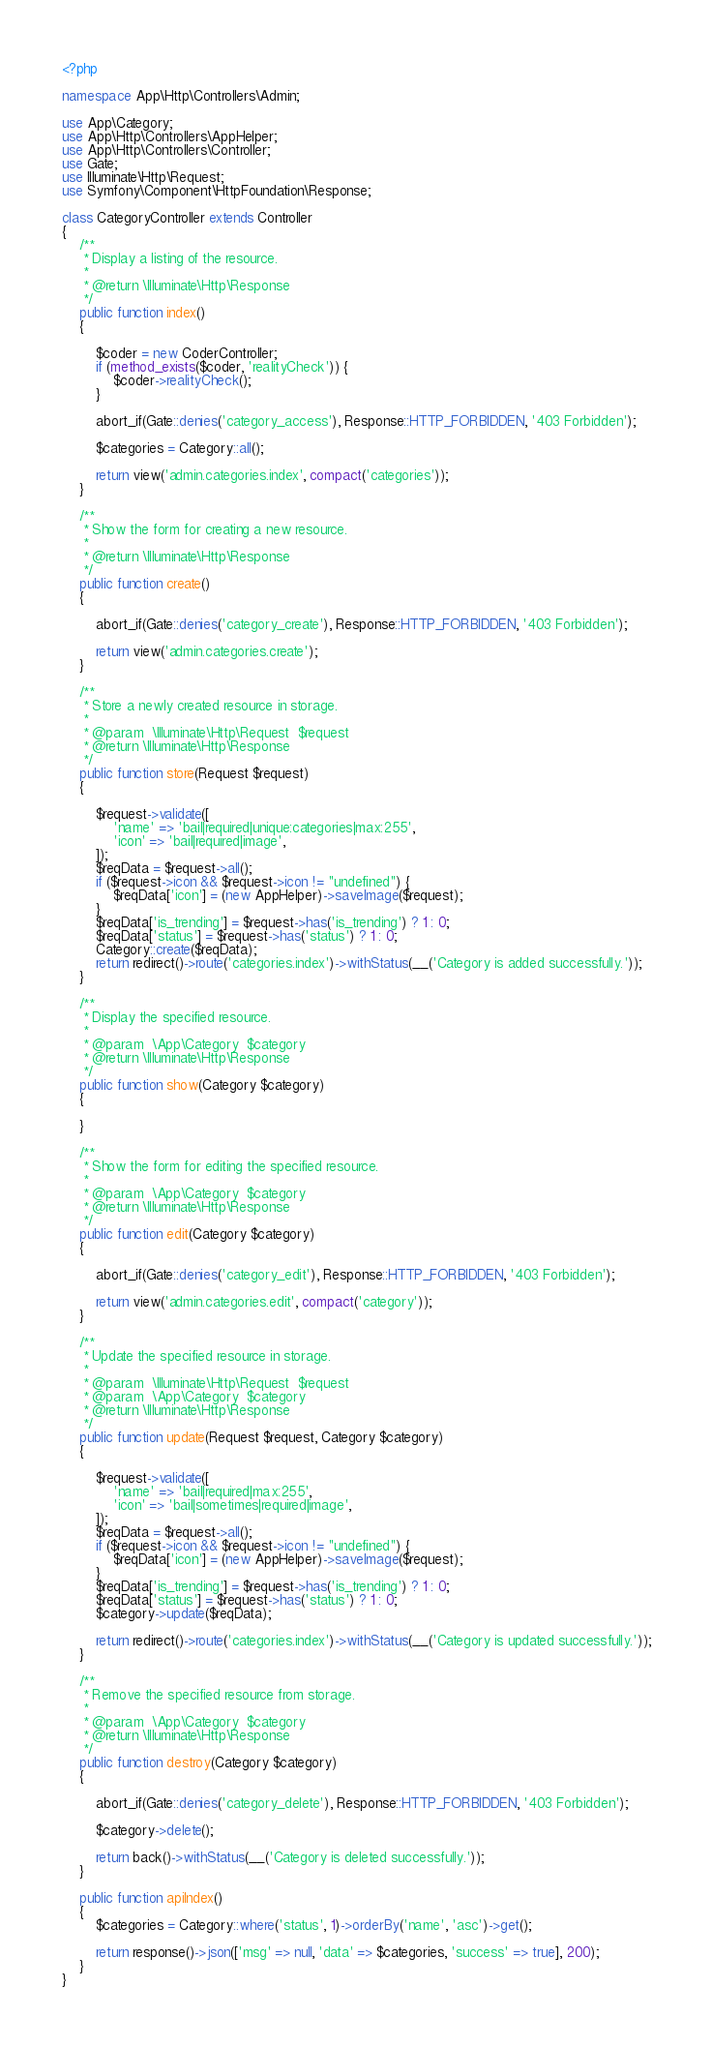Convert code to text. <code><loc_0><loc_0><loc_500><loc_500><_PHP_><?php

namespace App\Http\Controllers\Admin;

use App\Category;
use App\Http\Controllers\AppHelper;
use App\Http\Controllers\Controller;
use Gate;
use Illuminate\Http\Request;
use Symfony\Component\HttpFoundation\Response;

class CategoryController extends Controller
{
    /**
     * Display a listing of the resource.
     *
     * @return \Illuminate\Http\Response
     */
    public function index()
    {

        $coder = new CoderController;
        if (method_exists($coder, 'realityCheck')) {
            $coder->realityCheck();
        }

        abort_if(Gate::denies('category_access'), Response::HTTP_FORBIDDEN, '403 Forbidden');

        $categories = Category::all();

        return view('admin.categories.index', compact('categories'));
    }

    /**
     * Show the form for creating a new resource.
     *
     * @return \Illuminate\Http\Response
     */
    public function create()
    {

        abort_if(Gate::denies('category_create'), Response::HTTP_FORBIDDEN, '403 Forbidden');

        return view('admin.categories.create');
    }

    /**
     * Store a newly created resource in storage.
     *
     * @param  \Illuminate\Http\Request  $request
     * @return \Illuminate\Http\Response
     */
    public function store(Request $request)
    {

        $request->validate([
            'name' => 'bail|required|unique:categories|max:255',
            'icon' => 'bail|required|image',
        ]);
        $reqData = $request->all();
        if ($request->icon && $request->icon != "undefined") {
            $reqData['icon'] = (new AppHelper)->saveImage($request);
        }
        $reqData['is_trending'] = $request->has('is_trending') ? 1 : 0;
        $reqData['status'] = $request->has('status') ? 1 : 0;
        Category::create($reqData);
        return redirect()->route('categories.index')->withStatus(__('Category is added successfully.'));
    }

    /**
     * Display the specified resource.
     *
     * @param  \App\Category  $category
     * @return \Illuminate\Http\Response
     */
    public function show(Category $category)
    {

    }

    /**
     * Show the form for editing the specified resource.
     *
     * @param  \App\Category  $category
     * @return \Illuminate\Http\Response
     */
    public function edit(Category $category)
    {

        abort_if(Gate::denies('category_edit'), Response::HTTP_FORBIDDEN, '403 Forbidden');

        return view('admin.categories.edit', compact('category'));
    }

    /**
     * Update the specified resource in storage.
     *
     * @param  \Illuminate\Http\Request  $request
     * @param  \App\Category  $category
     * @return \Illuminate\Http\Response
     */
    public function update(Request $request, Category $category)
    {

        $request->validate([
            'name' => 'bail|required|max:255',
            'icon' => 'bail|sometimes|required|image',
        ]);
        $reqData = $request->all();
        if ($request->icon && $request->icon != "undefined") {
            $reqData['icon'] = (new AppHelper)->saveImage($request);
        }
        $reqData['is_trending'] = $request->has('is_trending') ? 1 : 0;
        $reqData['status'] = $request->has('status') ? 1 : 0;
        $category->update($reqData);

        return redirect()->route('categories.index')->withStatus(__('Category is updated successfully.'));
    }

    /**
     * Remove the specified resource from storage.
     *
     * @param  \App\Category  $category
     * @return \Illuminate\Http\Response
     */
    public function destroy(Category $category)
    {

        abort_if(Gate::denies('category_delete'), Response::HTTP_FORBIDDEN, '403 Forbidden');

        $category->delete();

        return back()->withStatus(__('Category is deleted successfully.'));
    }

    public function apiIndex()
    {
        $categories = Category::where('status', 1)->orderBy('name', 'asc')->get();

        return response()->json(['msg' => null, 'data' => $categories, 'success' => true], 200);
    }
}
</code> 